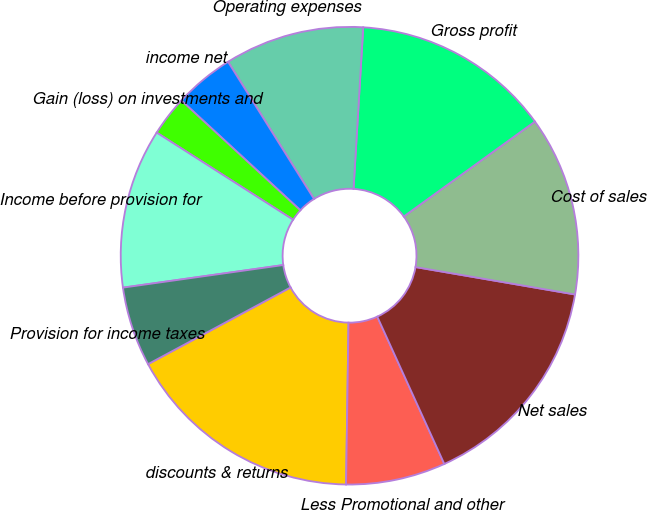Convert chart to OTSL. <chart><loc_0><loc_0><loc_500><loc_500><pie_chart><fcel>discounts & returns<fcel>Less Promotional and other<fcel>Net sales<fcel>Cost of sales<fcel>Gross profit<fcel>Operating expenses<fcel>income net<fcel>Gain (loss) on investments and<fcel>Income before provision for<fcel>Provision for income taxes<nl><fcel>16.9%<fcel>7.04%<fcel>15.49%<fcel>12.68%<fcel>14.08%<fcel>9.86%<fcel>4.23%<fcel>2.82%<fcel>11.27%<fcel>5.63%<nl></chart> 